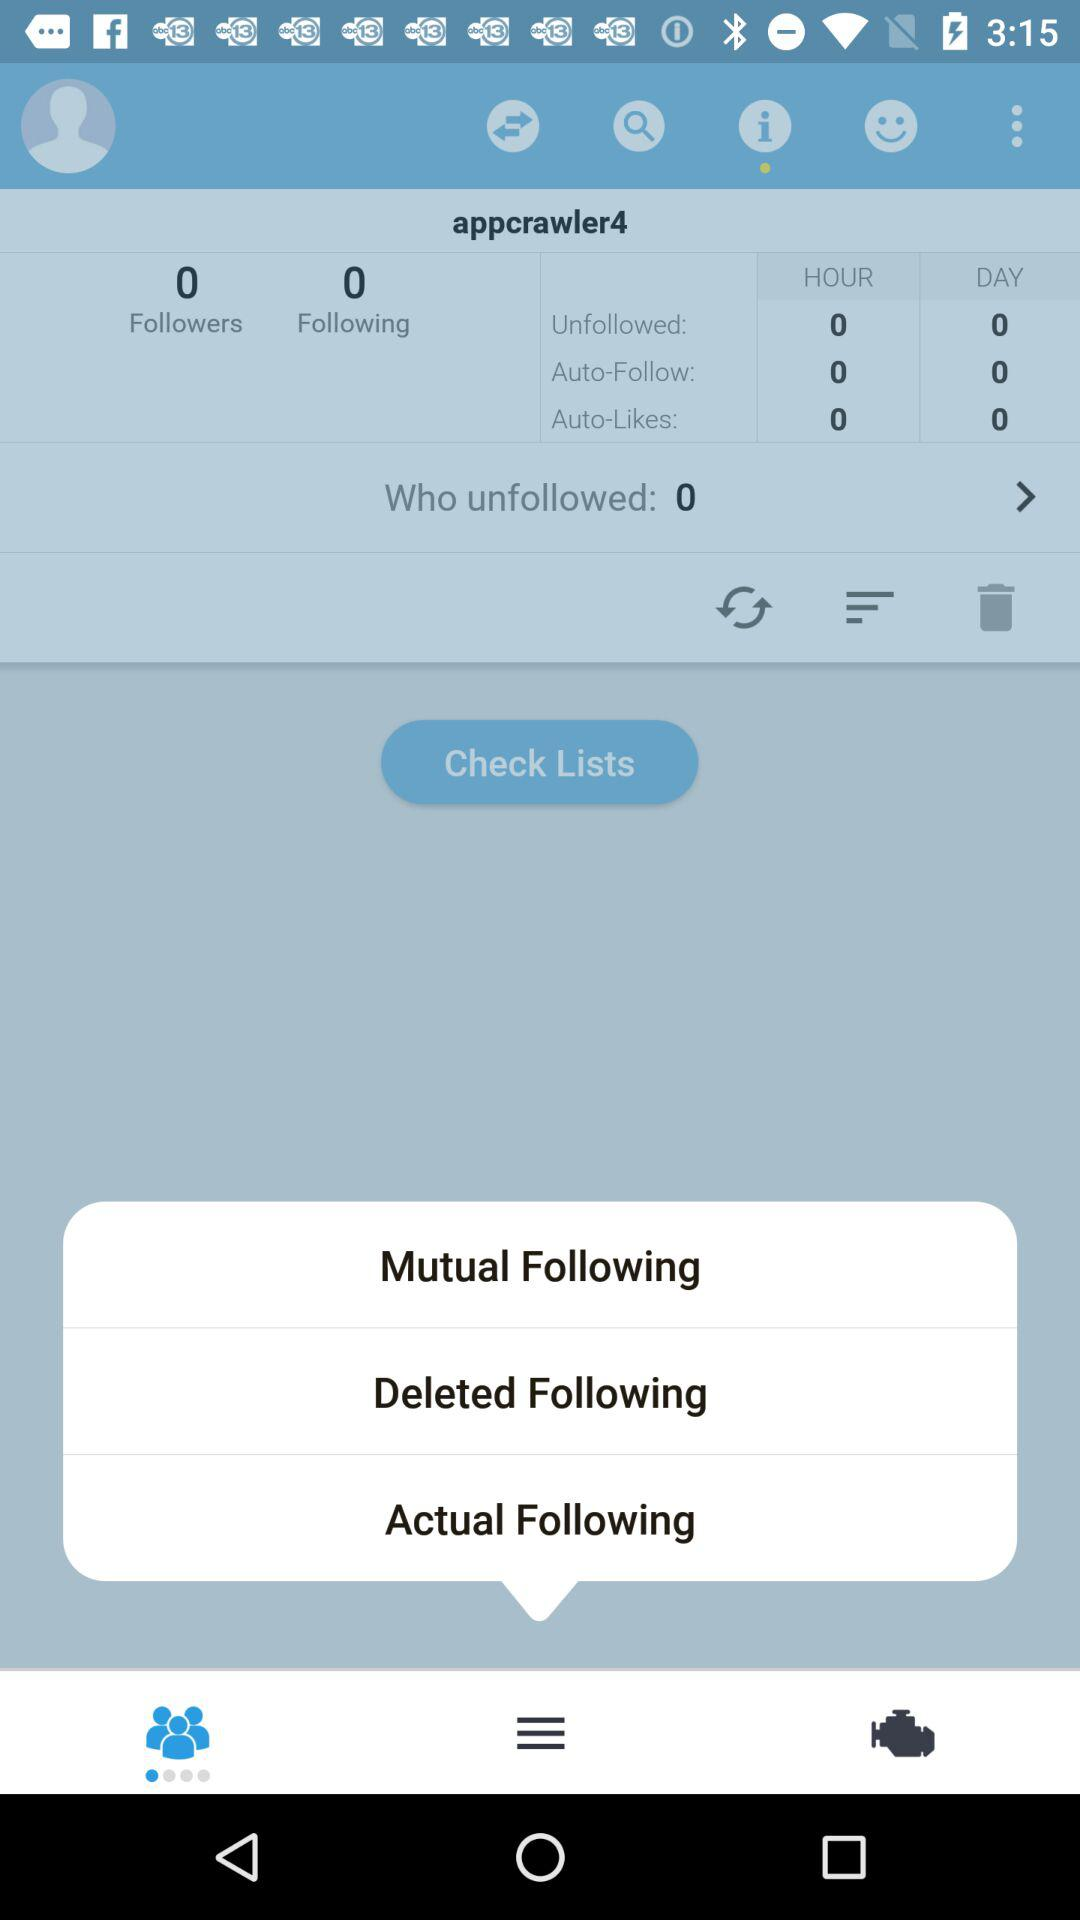How many options are shown in a check list?
When the provided information is insufficient, respond with <no answer>. <no answer> 